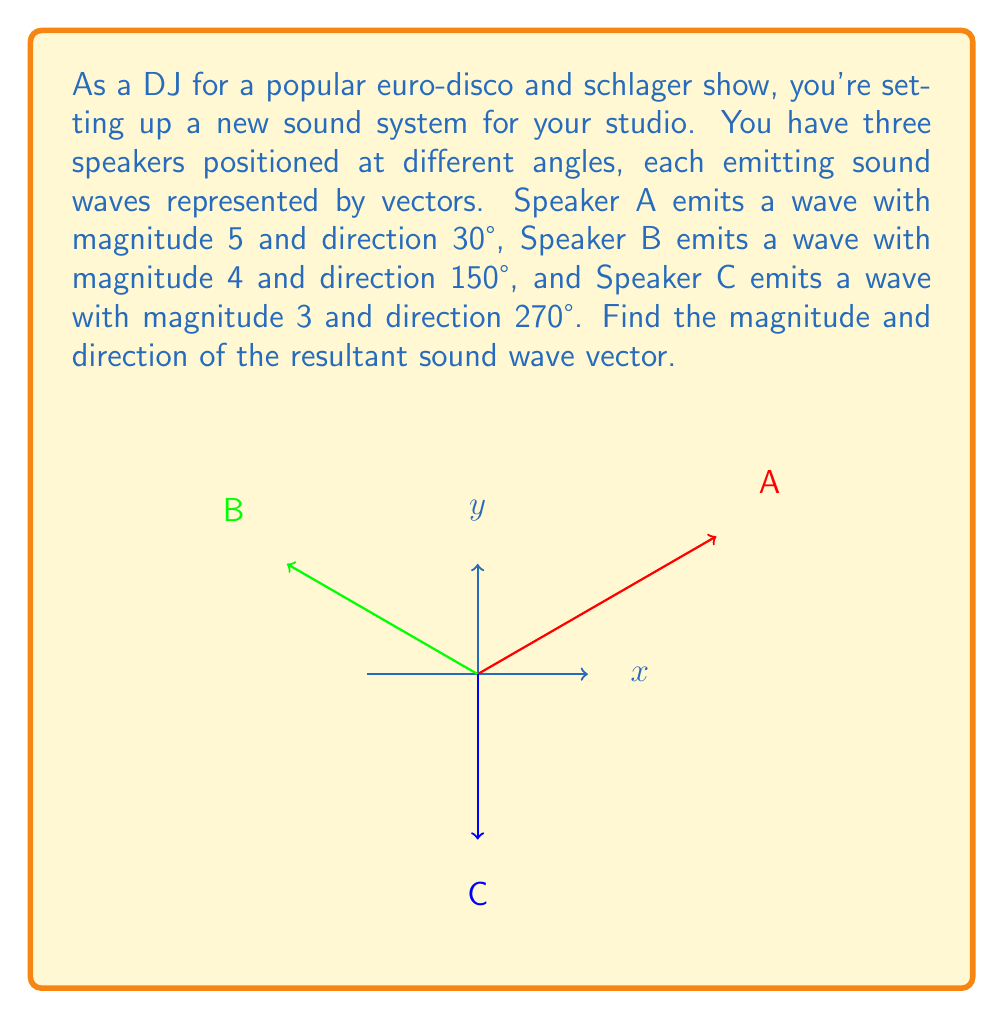Help me with this question. To find the resultant vector, we need to add these three vectors. Let's break it down step-by-step:

1) First, convert each vector to its rectangular (x,y) components:

   For Speaker A: $$(x_A, y_A) = (5\cos30°, 5\sin30°) = (4.33, 2.5)$$
   For Speaker B: $$(x_B, y_B) = (4\cos150°, 4\sin150°) = (-3.46, 2)$$
   For Speaker C: $$(x_C, y_C) = (3\cos270°, 3\sin270°) = (0, -3)$$

2) Add the x and y components separately:

   $$x_{total} = x_A + x_B + x_C = 4.33 + (-3.46) + 0 = 0.87$$
   $$y_{total} = y_A + y_B + y_C = 2.5 + 2 + (-3) = 1.5$$

3) The resultant vector is $(0.87, 1.5)$

4) To find the magnitude, use the Pythagorean theorem:

   $$magnitude = \sqrt{0.87^2 + 1.5^2} = \sqrt{0.7569 + 2.25} = \sqrt{3.0069} \approx 1.73$$

5) To find the direction (angle), use the arctangent function:

   $$\theta = \tan^{-1}(\frac{y_{total}}{x_{total}}) = \tan^{-1}(\frac{1.5}{0.87}) \approx 59.9°$$

Therefore, the resultant sound wave vector has a magnitude of approximately 1.73 and a direction of about 59.9° from the positive x-axis.
Answer: Magnitude ≈ 1.73, Direction ≈ 59.9° 